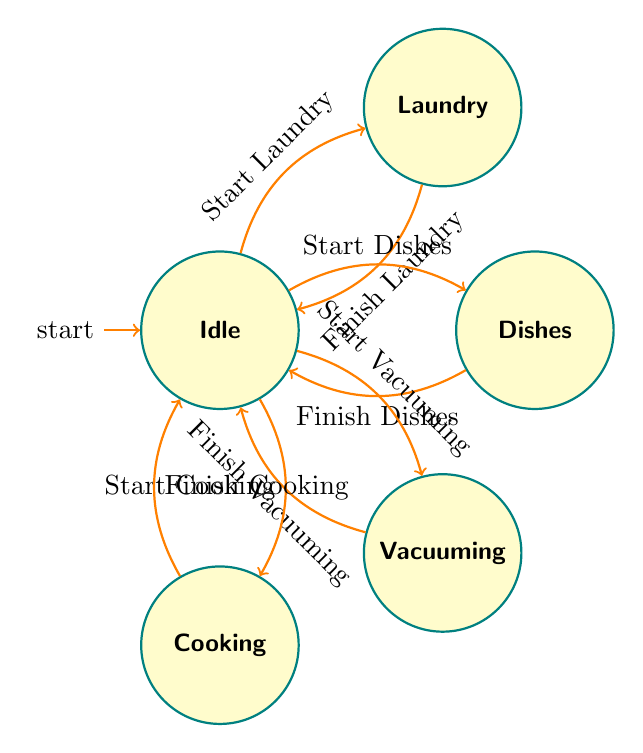What are the states in the diagram? The states are the different activities that can be performed and are represented as nodes. They include "Idle," "Laundry," "Dishes," "Vacuuming," and "Cooking."
Answer: Idle, Laundry, Dishes, Vacuuming, Cooking How many transitions are there in total? Transitions refer to the arrows that indicate movement from one state to another. There are eight transitions listed in the diagram: "Start Laundry," "Finish Laundry," "Start Dishes," "Finish Dishes," "Start Vacuuming," "Finish Vacuuming," "Start Cooking," and "Finish Cooking."
Answer: Eight Which state do you go to after finishing dishes? The transition "Finish Dishes" leads back to the "Idle" state, indicating that completing the dishes returns to a state of no chores.
Answer: Idle What is the first action taken from the idle state? The actions that can be initiated from the "Idle" state are represented by transitions leading to other chores. The first possible actions, in this case, are "Start Laundry," "Start Dishes," "Start Vacuuming," and "Start Cooking," but the first in the transition list is "Start Laundry."
Answer: Start Laundry If you are in the cooking state, what will happen when you finish cooking? Upon finishing cooking, the transition indicated as "Finish Cooking" leads back to the "Idle" state, meaning the cooking task is completed and the household returns to no active chores.
Answer: Idle What state transitions occur after starting laundry? Starting laundry moves the state from "Idle" to "Laundry," indicating a chore has been initiated, and once the laundry task is completed through the transition, it goes back to "Idle."
Answer: Laundry to Idle How many nodes represent active chores in the diagram? The active chores that are represented as distinct states in the diagram are "Laundry," "Dishes," "Vacuuming," and "Cooking," totaling four nodes.
Answer: Four What happens when you start vacuuming from idle? When vacuuming is started from the idle state, the transition "Start Vacuuming" moves the state to "Vacuuming," indicating that vacuuming has now begun as an active chore.
Answer: Vacuuming 